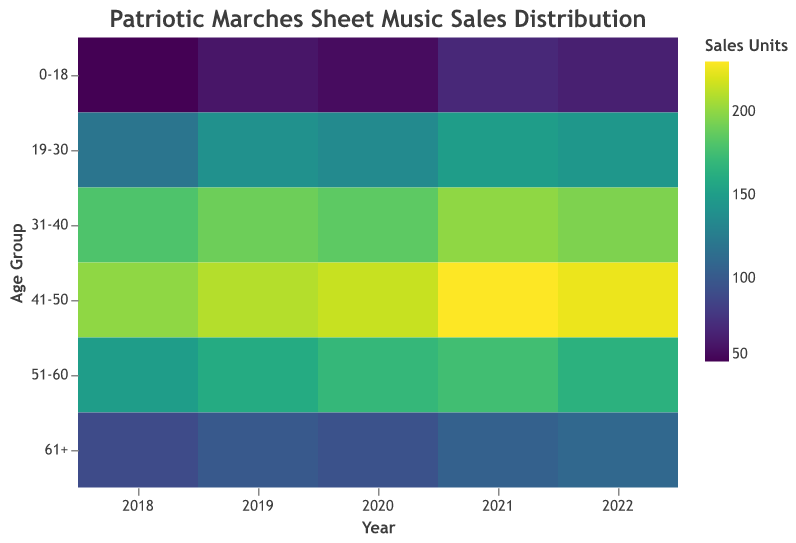What is the title of the heatmap? The title is usually positioned at the top of the figure and is intended to give an overview of what the figure represents. In this case, it is provided within the visualization specifications.
Answer: Patriotic Marches Sheet Music Sales Distribution Which age group had the highest sales units in 2021? Look at the color representing sales units for each age group in 2021; the darkest or brightest color indicates higher sales. Here, the age group 41-50 will have the highest sales as it shows the darkest/brightest color.
Answer: 41-50 How did the sales units change for the age group 0-18 from 2018 to 2022? To determine this, trace the color change for the age group 0-18 across the years from 2018 to 2022. A visible transition to a darker/brighter color suggests an increase in sales units. Here, sales went from 50 units in 2018 to 65 units in 2022.
Answer: Increased by 15 units What is the sales unit difference between age groups 31-40 and 51-60 in 2020? Locate the sales units for both age groups in 2020, then calculate the difference: 185 (31-40) - 170 (51-60).
Answer: 15 units Which year had the highest overall sales for the age group 61+? Look at the colors representing the sales units for the age group 61+ across all given years; the darkest/brightest color indicates the highest sales. Here, 2022 had the highest sales.
Answer: 2022 What is the trend in sales units for the age group 19-30 between 2018 and 2021? Identify the color changes for the age group 19-30 from 2018 to 2021 and infer the trend from light to dark/bright: sales trend shows a gradual increase.
Answer: Increasing Which age group had the least sales in 2018? Identify the lightest color bar for the year 2018, which indicates the fewest sales units. Here, the age group 0-18 had the least sales.
Answer: 0-18 How does the sales unit for the age group 41-50 in 2022 compare to the same age group in 2019? Compare the intensity of the color for the age group 41-50 in 2022 with 2019. The sales units for 2022 (225) are higher than for 2019 (210).
Answer: Higher in 2022 What is the average sales units for the age group 51-60 over the five years? Sum the sales units for the age group 51-60 for each year (150, 160, 170, 175, 165), then divide by the number of years (5): (150 + 160 + 170 + 175 + 165) / 5 = 164 units.
Answer: 164 units 